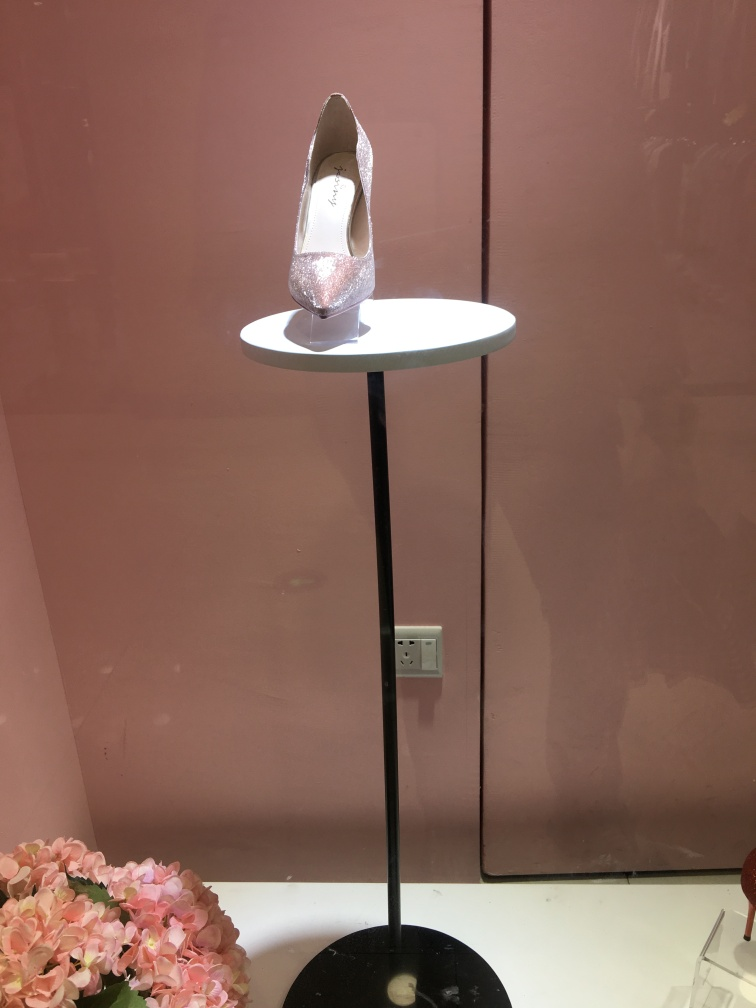Can you describe the unique features of the shoe on display? Certainly, the shoe features a sparkling, glitter-encrusted exterior that radiates in the light, presumably to captivate potential customers. It has a classic high-heeled pump design with a pointed toe, which suggests sophistication and a formal style. The shoe appears to be a single display piece, indicating it might be a highlighted item or part of a new collection. 